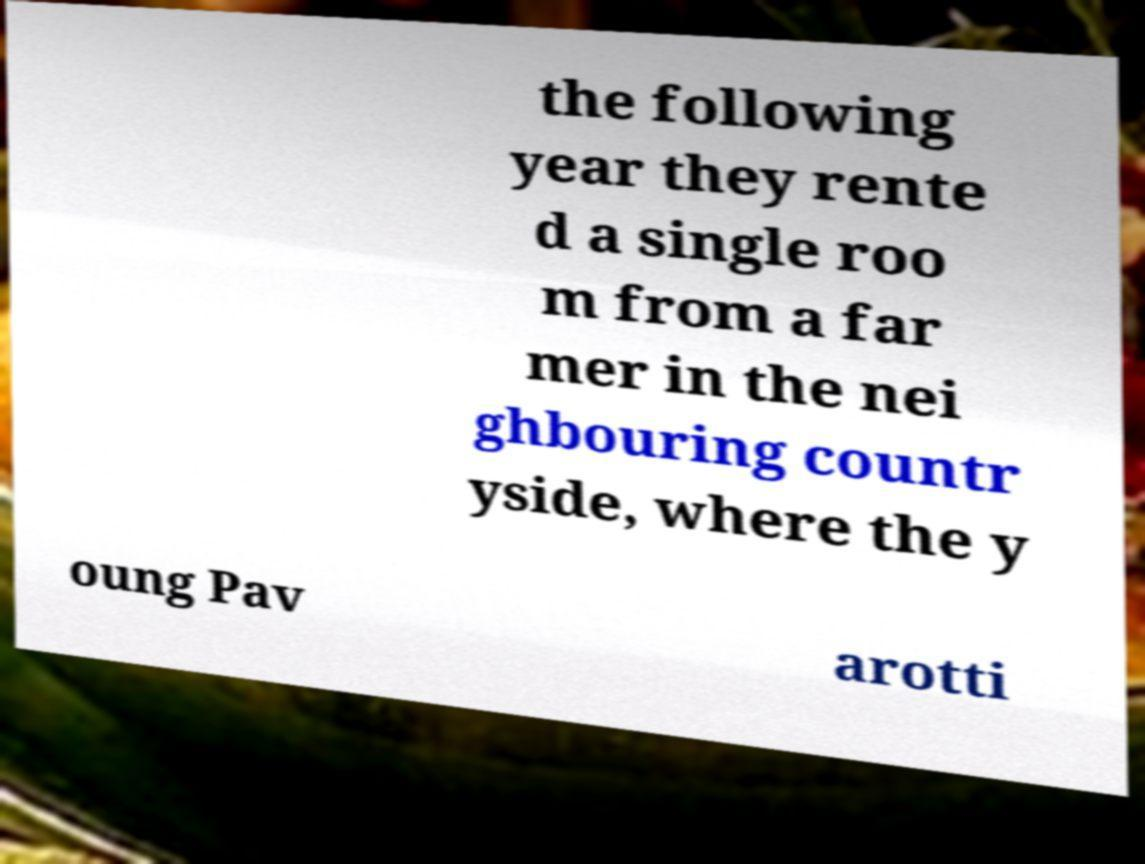Please read and relay the text visible in this image. What does it say? the following year they rente d a single roo m from a far mer in the nei ghbouring countr yside, where the y oung Pav arotti 